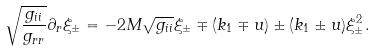<formula> <loc_0><loc_0><loc_500><loc_500>\sqrt { \frac { g _ { i i } } { g _ { r r } } } \partial _ { r } \xi _ { \pm } = - 2 M \sqrt { g _ { i i } } \xi _ { \pm } \mp ( k _ { 1 } \mp u ) \pm ( k _ { 1 } \pm u ) \xi _ { \pm } ^ { 2 } .</formula> 